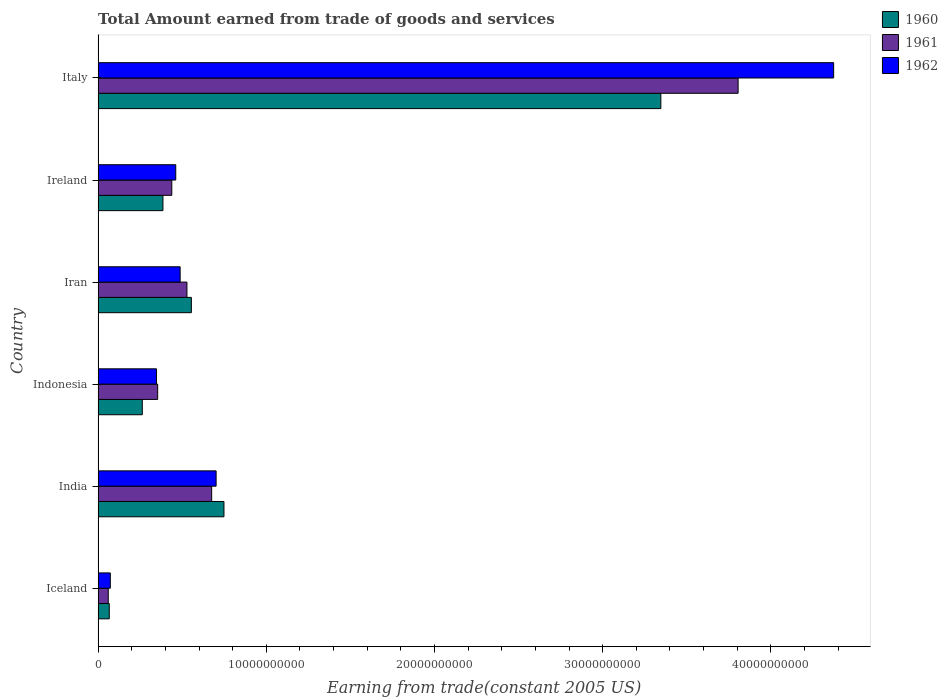How many different coloured bars are there?
Offer a very short reply. 3. How many groups of bars are there?
Your answer should be very brief. 6. How many bars are there on the 3rd tick from the top?
Provide a short and direct response. 3. In how many cases, is the number of bars for a given country not equal to the number of legend labels?
Your answer should be very brief. 0. What is the total amount earned by trading goods and services in 1962 in Ireland?
Your response must be concise. 4.62e+09. Across all countries, what is the maximum total amount earned by trading goods and services in 1961?
Your response must be concise. 3.81e+1. Across all countries, what is the minimum total amount earned by trading goods and services in 1961?
Your answer should be very brief. 6.03e+08. What is the total total amount earned by trading goods and services in 1962 in the graph?
Make the answer very short. 6.44e+1. What is the difference between the total amount earned by trading goods and services in 1960 in Indonesia and that in Italy?
Offer a very short reply. -3.08e+1. What is the difference between the total amount earned by trading goods and services in 1962 in Iceland and the total amount earned by trading goods and services in 1960 in Indonesia?
Your response must be concise. -1.90e+09. What is the average total amount earned by trading goods and services in 1961 per country?
Your answer should be very brief. 9.77e+09. What is the difference between the total amount earned by trading goods and services in 1961 and total amount earned by trading goods and services in 1962 in Iceland?
Provide a succinct answer. -1.22e+08. What is the ratio of the total amount earned by trading goods and services in 1962 in Iceland to that in Iran?
Offer a very short reply. 0.15. Is the total amount earned by trading goods and services in 1962 in India less than that in Iran?
Your response must be concise. No. What is the difference between the highest and the second highest total amount earned by trading goods and services in 1961?
Ensure brevity in your answer.  3.13e+1. What is the difference between the highest and the lowest total amount earned by trading goods and services in 1961?
Your answer should be compact. 3.74e+1. Is the sum of the total amount earned by trading goods and services in 1961 in Iran and Ireland greater than the maximum total amount earned by trading goods and services in 1960 across all countries?
Your answer should be compact. No. What does the 3rd bar from the top in Italy represents?
Your answer should be very brief. 1960. What does the 1st bar from the bottom in Ireland represents?
Make the answer very short. 1960. Is it the case that in every country, the sum of the total amount earned by trading goods and services in 1961 and total amount earned by trading goods and services in 1960 is greater than the total amount earned by trading goods and services in 1962?
Your answer should be very brief. Yes. How many bars are there?
Offer a very short reply. 18. How many countries are there in the graph?
Offer a very short reply. 6. Are the values on the major ticks of X-axis written in scientific E-notation?
Your answer should be very brief. No. Where does the legend appear in the graph?
Offer a terse response. Top right. How many legend labels are there?
Provide a succinct answer. 3. What is the title of the graph?
Offer a very short reply. Total Amount earned from trade of goods and services. What is the label or title of the X-axis?
Provide a succinct answer. Earning from trade(constant 2005 US). What is the Earning from trade(constant 2005 US) in 1960 in Iceland?
Provide a succinct answer. 6.63e+08. What is the Earning from trade(constant 2005 US) in 1961 in Iceland?
Your answer should be very brief. 6.03e+08. What is the Earning from trade(constant 2005 US) in 1962 in Iceland?
Offer a terse response. 7.25e+08. What is the Earning from trade(constant 2005 US) of 1960 in India?
Provide a succinct answer. 7.48e+09. What is the Earning from trade(constant 2005 US) in 1961 in India?
Make the answer very short. 6.75e+09. What is the Earning from trade(constant 2005 US) of 1962 in India?
Offer a very short reply. 7.02e+09. What is the Earning from trade(constant 2005 US) of 1960 in Indonesia?
Your response must be concise. 2.63e+09. What is the Earning from trade(constant 2005 US) of 1961 in Indonesia?
Provide a succinct answer. 3.54e+09. What is the Earning from trade(constant 2005 US) in 1962 in Indonesia?
Provide a succinct answer. 3.47e+09. What is the Earning from trade(constant 2005 US) in 1960 in Iran?
Ensure brevity in your answer.  5.54e+09. What is the Earning from trade(constant 2005 US) of 1961 in Iran?
Your answer should be compact. 5.28e+09. What is the Earning from trade(constant 2005 US) in 1962 in Iran?
Offer a very short reply. 4.88e+09. What is the Earning from trade(constant 2005 US) in 1960 in Ireland?
Your response must be concise. 3.85e+09. What is the Earning from trade(constant 2005 US) in 1961 in Ireland?
Your response must be concise. 4.38e+09. What is the Earning from trade(constant 2005 US) of 1962 in Ireland?
Your answer should be compact. 4.62e+09. What is the Earning from trade(constant 2005 US) of 1960 in Italy?
Keep it short and to the point. 3.35e+1. What is the Earning from trade(constant 2005 US) in 1961 in Italy?
Your answer should be very brief. 3.81e+1. What is the Earning from trade(constant 2005 US) of 1962 in Italy?
Provide a succinct answer. 4.37e+1. Across all countries, what is the maximum Earning from trade(constant 2005 US) in 1960?
Your answer should be very brief. 3.35e+1. Across all countries, what is the maximum Earning from trade(constant 2005 US) of 1961?
Offer a terse response. 3.81e+1. Across all countries, what is the maximum Earning from trade(constant 2005 US) in 1962?
Your answer should be compact. 4.37e+1. Across all countries, what is the minimum Earning from trade(constant 2005 US) in 1960?
Make the answer very short. 6.63e+08. Across all countries, what is the minimum Earning from trade(constant 2005 US) in 1961?
Provide a succinct answer. 6.03e+08. Across all countries, what is the minimum Earning from trade(constant 2005 US) in 1962?
Keep it short and to the point. 7.25e+08. What is the total Earning from trade(constant 2005 US) in 1960 in the graph?
Keep it short and to the point. 5.36e+1. What is the total Earning from trade(constant 2005 US) in 1961 in the graph?
Your answer should be very brief. 5.86e+1. What is the total Earning from trade(constant 2005 US) in 1962 in the graph?
Your answer should be very brief. 6.44e+1. What is the difference between the Earning from trade(constant 2005 US) in 1960 in Iceland and that in India?
Ensure brevity in your answer.  -6.82e+09. What is the difference between the Earning from trade(constant 2005 US) of 1961 in Iceland and that in India?
Your answer should be very brief. -6.15e+09. What is the difference between the Earning from trade(constant 2005 US) in 1962 in Iceland and that in India?
Keep it short and to the point. -6.29e+09. What is the difference between the Earning from trade(constant 2005 US) of 1960 in Iceland and that in Indonesia?
Provide a succinct answer. -1.96e+09. What is the difference between the Earning from trade(constant 2005 US) of 1961 in Iceland and that in Indonesia?
Offer a terse response. -2.94e+09. What is the difference between the Earning from trade(constant 2005 US) of 1962 in Iceland and that in Indonesia?
Ensure brevity in your answer.  -2.75e+09. What is the difference between the Earning from trade(constant 2005 US) in 1960 in Iceland and that in Iran?
Give a very brief answer. -4.88e+09. What is the difference between the Earning from trade(constant 2005 US) of 1961 in Iceland and that in Iran?
Your response must be concise. -4.68e+09. What is the difference between the Earning from trade(constant 2005 US) of 1962 in Iceland and that in Iran?
Offer a very short reply. -4.15e+09. What is the difference between the Earning from trade(constant 2005 US) of 1960 in Iceland and that in Ireland?
Provide a short and direct response. -3.19e+09. What is the difference between the Earning from trade(constant 2005 US) of 1961 in Iceland and that in Ireland?
Provide a short and direct response. -3.78e+09. What is the difference between the Earning from trade(constant 2005 US) of 1962 in Iceland and that in Ireland?
Give a very brief answer. -3.89e+09. What is the difference between the Earning from trade(constant 2005 US) of 1960 in Iceland and that in Italy?
Make the answer very short. -3.28e+1. What is the difference between the Earning from trade(constant 2005 US) of 1961 in Iceland and that in Italy?
Ensure brevity in your answer.  -3.74e+1. What is the difference between the Earning from trade(constant 2005 US) in 1962 in Iceland and that in Italy?
Your answer should be very brief. -4.30e+1. What is the difference between the Earning from trade(constant 2005 US) of 1960 in India and that in Indonesia?
Your answer should be compact. 4.85e+09. What is the difference between the Earning from trade(constant 2005 US) of 1961 in India and that in Indonesia?
Make the answer very short. 3.21e+09. What is the difference between the Earning from trade(constant 2005 US) in 1962 in India and that in Indonesia?
Your answer should be compact. 3.54e+09. What is the difference between the Earning from trade(constant 2005 US) in 1960 in India and that in Iran?
Your answer should be very brief. 1.94e+09. What is the difference between the Earning from trade(constant 2005 US) of 1961 in India and that in Iran?
Ensure brevity in your answer.  1.47e+09. What is the difference between the Earning from trade(constant 2005 US) of 1962 in India and that in Iran?
Your response must be concise. 2.14e+09. What is the difference between the Earning from trade(constant 2005 US) of 1960 in India and that in Ireland?
Make the answer very short. 3.63e+09. What is the difference between the Earning from trade(constant 2005 US) of 1961 in India and that in Ireland?
Your answer should be compact. 2.37e+09. What is the difference between the Earning from trade(constant 2005 US) of 1962 in India and that in Ireland?
Ensure brevity in your answer.  2.40e+09. What is the difference between the Earning from trade(constant 2005 US) in 1960 in India and that in Italy?
Your response must be concise. -2.60e+1. What is the difference between the Earning from trade(constant 2005 US) of 1961 in India and that in Italy?
Your response must be concise. -3.13e+1. What is the difference between the Earning from trade(constant 2005 US) of 1962 in India and that in Italy?
Give a very brief answer. -3.67e+1. What is the difference between the Earning from trade(constant 2005 US) of 1960 in Indonesia and that in Iran?
Offer a very short reply. -2.92e+09. What is the difference between the Earning from trade(constant 2005 US) of 1961 in Indonesia and that in Iran?
Ensure brevity in your answer.  -1.74e+09. What is the difference between the Earning from trade(constant 2005 US) of 1962 in Indonesia and that in Iran?
Offer a very short reply. -1.40e+09. What is the difference between the Earning from trade(constant 2005 US) in 1960 in Indonesia and that in Ireland?
Your answer should be very brief. -1.23e+09. What is the difference between the Earning from trade(constant 2005 US) of 1961 in Indonesia and that in Ireland?
Your response must be concise. -8.41e+08. What is the difference between the Earning from trade(constant 2005 US) in 1962 in Indonesia and that in Ireland?
Your answer should be compact. -1.14e+09. What is the difference between the Earning from trade(constant 2005 US) of 1960 in Indonesia and that in Italy?
Your response must be concise. -3.08e+1. What is the difference between the Earning from trade(constant 2005 US) of 1961 in Indonesia and that in Italy?
Keep it short and to the point. -3.45e+1. What is the difference between the Earning from trade(constant 2005 US) in 1962 in Indonesia and that in Italy?
Ensure brevity in your answer.  -4.03e+1. What is the difference between the Earning from trade(constant 2005 US) of 1960 in Iran and that in Ireland?
Give a very brief answer. 1.69e+09. What is the difference between the Earning from trade(constant 2005 US) in 1961 in Iran and that in Ireland?
Provide a short and direct response. 9.00e+08. What is the difference between the Earning from trade(constant 2005 US) in 1962 in Iran and that in Ireland?
Ensure brevity in your answer.  2.61e+08. What is the difference between the Earning from trade(constant 2005 US) in 1960 in Iran and that in Italy?
Keep it short and to the point. -2.79e+1. What is the difference between the Earning from trade(constant 2005 US) of 1961 in Iran and that in Italy?
Make the answer very short. -3.28e+1. What is the difference between the Earning from trade(constant 2005 US) of 1962 in Iran and that in Italy?
Offer a terse response. -3.89e+1. What is the difference between the Earning from trade(constant 2005 US) of 1960 in Ireland and that in Italy?
Give a very brief answer. -2.96e+1. What is the difference between the Earning from trade(constant 2005 US) of 1961 in Ireland and that in Italy?
Your response must be concise. -3.37e+1. What is the difference between the Earning from trade(constant 2005 US) in 1962 in Ireland and that in Italy?
Make the answer very short. -3.91e+1. What is the difference between the Earning from trade(constant 2005 US) of 1960 in Iceland and the Earning from trade(constant 2005 US) of 1961 in India?
Provide a short and direct response. -6.09e+09. What is the difference between the Earning from trade(constant 2005 US) of 1960 in Iceland and the Earning from trade(constant 2005 US) of 1962 in India?
Give a very brief answer. -6.35e+09. What is the difference between the Earning from trade(constant 2005 US) in 1961 in Iceland and the Earning from trade(constant 2005 US) in 1962 in India?
Ensure brevity in your answer.  -6.41e+09. What is the difference between the Earning from trade(constant 2005 US) of 1960 in Iceland and the Earning from trade(constant 2005 US) of 1961 in Indonesia?
Keep it short and to the point. -2.88e+09. What is the difference between the Earning from trade(constant 2005 US) of 1960 in Iceland and the Earning from trade(constant 2005 US) of 1962 in Indonesia?
Your answer should be very brief. -2.81e+09. What is the difference between the Earning from trade(constant 2005 US) in 1961 in Iceland and the Earning from trade(constant 2005 US) in 1962 in Indonesia?
Offer a terse response. -2.87e+09. What is the difference between the Earning from trade(constant 2005 US) of 1960 in Iceland and the Earning from trade(constant 2005 US) of 1961 in Iran?
Your response must be concise. -4.62e+09. What is the difference between the Earning from trade(constant 2005 US) of 1960 in Iceland and the Earning from trade(constant 2005 US) of 1962 in Iran?
Make the answer very short. -4.21e+09. What is the difference between the Earning from trade(constant 2005 US) in 1961 in Iceland and the Earning from trade(constant 2005 US) in 1962 in Iran?
Offer a terse response. -4.27e+09. What is the difference between the Earning from trade(constant 2005 US) in 1960 in Iceland and the Earning from trade(constant 2005 US) in 1961 in Ireland?
Offer a very short reply. -3.72e+09. What is the difference between the Earning from trade(constant 2005 US) of 1960 in Iceland and the Earning from trade(constant 2005 US) of 1962 in Ireland?
Ensure brevity in your answer.  -3.95e+09. What is the difference between the Earning from trade(constant 2005 US) of 1961 in Iceland and the Earning from trade(constant 2005 US) of 1962 in Ireland?
Give a very brief answer. -4.01e+09. What is the difference between the Earning from trade(constant 2005 US) of 1960 in Iceland and the Earning from trade(constant 2005 US) of 1961 in Italy?
Offer a terse response. -3.74e+1. What is the difference between the Earning from trade(constant 2005 US) in 1960 in Iceland and the Earning from trade(constant 2005 US) in 1962 in Italy?
Give a very brief answer. -4.31e+1. What is the difference between the Earning from trade(constant 2005 US) in 1961 in Iceland and the Earning from trade(constant 2005 US) in 1962 in Italy?
Your response must be concise. -4.31e+1. What is the difference between the Earning from trade(constant 2005 US) in 1960 in India and the Earning from trade(constant 2005 US) in 1961 in Indonesia?
Provide a succinct answer. 3.94e+09. What is the difference between the Earning from trade(constant 2005 US) of 1960 in India and the Earning from trade(constant 2005 US) of 1962 in Indonesia?
Your answer should be compact. 4.01e+09. What is the difference between the Earning from trade(constant 2005 US) of 1961 in India and the Earning from trade(constant 2005 US) of 1962 in Indonesia?
Give a very brief answer. 3.28e+09. What is the difference between the Earning from trade(constant 2005 US) in 1960 in India and the Earning from trade(constant 2005 US) in 1961 in Iran?
Your response must be concise. 2.20e+09. What is the difference between the Earning from trade(constant 2005 US) in 1960 in India and the Earning from trade(constant 2005 US) in 1962 in Iran?
Make the answer very short. 2.60e+09. What is the difference between the Earning from trade(constant 2005 US) of 1961 in India and the Earning from trade(constant 2005 US) of 1962 in Iran?
Provide a succinct answer. 1.87e+09. What is the difference between the Earning from trade(constant 2005 US) of 1960 in India and the Earning from trade(constant 2005 US) of 1961 in Ireland?
Keep it short and to the point. 3.10e+09. What is the difference between the Earning from trade(constant 2005 US) of 1960 in India and the Earning from trade(constant 2005 US) of 1962 in Ireland?
Provide a succinct answer. 2.87e+09. What is the difference between the Earning from trade(constant 2005 US) in 1961 in India and the Earning from trade(constant 2005 US) in 1962 in Ireland?
Offer a terse response. 2.14e+09. What is the difference between the Earning from trade(constant 2005 US) in 1960 in India and the Earning from trade(constant 2005 US) in 1961 in Italy?
Your answer should be very brief. -3.06e+1. What is the difference between the Earning from trade(constant 2005 US) in 1960 in India and the Earning from trade(constant 2005 US) in 1962 in Italy?
Offer a terse response. -3.62e+1. What is the difference between the Earning from trade(constant 2005 US) in 1961 in India and the Earning from trade(constant 2005 US) in 1962 in Italy?
Keep it short and to the point. -3.70e+1. What is the difference between the Earning from trade(constant 2005 US) in 1960 in Indonesia and the Earning from trade(constant 2005 US) in 1961 in Iran?
Offer a terse response. -2.65e+09. What is the difference between the Earning from trade(constant 2005 US) in 1960 in Indonesia and the Earning from trade(constant 2005 US) in 1962 in Iran?
Ensure brevity in your answer.  -2.25e+09. What is the difference between the Earning from trade(constant 2005 US) of 1961 in Indonesia and the Earning from trade(constant 2005 US) of 1962 in Iran?
Provide a short and direct response. -1.34e+09. What is the difference between the Earning from trade(constant 2005 US) of 1960 in Indonesia and the Earning from trade(constant 2005 US) of 1961 in Ireland?
Offer a terse response. -1.75e+09. What is the difference between the Earning from trade(constant 2005 US) of 1960 in Indonesia and the Earning from trade(constant 2005 US) of 1962 in Ireland?
Your answer should be very brief. -1.99e+09. What is the difference between the Earning from trade(constant 2005 US) of 1961 in Indonesia and the Earning from trade(constant 2005 US) of 1962 in Ireland?
Your response must be concise. -1.08e+09. What is the difference between the Earning from trade(constant 2005 US) of 1960 in Indonesia and the Earning from trade(constant 2005 US) of 1961 in Italy?
Offer a terse response. -3.54e+1. What is the difference between the Earning from trade(constant 2005 US) of 1960 in Indonesia and the Earning from trade(constant 2005 US) of 1962 in Italy?
Provide a succinct answer. -4.11e+1. What is the difference between the Earning from trade(constant 2005 US) in 1961 in Indonesia and the Earning from trade(constant 2005 US) in 1962 in Italy?
Provide a short and direct response. -4.02e+1. What is the difference between the Earning from trade(constant 2005 US) of 1960 in Iran and the Earning from trade(constant 2005 US) of 1961 in Ireland?
Make the answer very short. 1.16e+09. What is the difference between the Earning from trade(constant 2005 US) of 1960 in Iran and the Earning from trade(constant 2005 US) of 1962 in Ireland?
Offer a terse response. 9.28e+08. What is the difference between the Earning from trade(constant 2005 US) in 1961 in Iran and the Earning from trade(constant 2005 US) in 1962 in Ireland?
Offer a very short reply. 6.65e+08. What is the difference between the Earning from trade(constant 2005 US) in 1960 in Iran and the Earning from trade(constant 2005 US) in 1961 in Italy?
Provide a short and direct response. -3.25e+1. What is the difference between the Earning from trade(constant 2005 US) of 1960 in Iran and the Earning from trade(constant 2005 US) of 1962 in Italy?
Your response must be concise. -3.82e+1. What is the difference between the Earning from trade(constant 2005 US) of 1961 in Iran and the Earning from trade(constant 2005 US) of 1962 in Italy?
Make the answer very short. -3.85e+1. What is the difference between the Earning from trade(constant 2005 US) in 1960 in Ireland and the Earning from trade(constant 2005 US) in 1961 in Italy?
Ensure brevity in your answer.  -3.42e+1. What is the difference between the Earning from trade(constant 2005 US) of 1960 in Ireland and the Earning from trade(constant 2005 US) of 1962 in Italy?
Offer a terse response. -3.99e+1. What is the difference between the Earning from trade(constant 2005 US) of 1961 in Ireland and the Earning from trade(constant 2005 US) of 1962 in Italy?
Provide a succinct answer. -3.93e+1. What is the average Earning from trade(constant 2005 US) of 1960 per country?
Give a very brief answer. 8.94e+09. What is the average Earning from trade(constant 2005 US) in 1961 per country?
Provide a succinct answer. 9.77e+09. What is the average Earning from trade(constant 2005 US) of 1962 per country?
Your response must be concise. 1.07e+1. What is the difference between the Earning from trade(constant 2005 US) of 1960 and Earning from trade(constant 2005 US) of 1961 in Iceland?
Keep it short and to the point. 6.00e+07. What is the difference between the Earning from trade(constant 2005 US) in 1960 and Earning from trade(constant 2005 US) in 1962 in Iceland?
Offer a very short reply. -6.22e+07. What is the difference between the Earning from trade(constant 2005 US) of 1961 and Earning from trade(constant 2005 US) of 1962 in Iceland?
Give a very brief answer. -1.22e+08. What is the difference between the Earning from trade(constant 2005 US) in 1960 and Earning from trade(constant 2005 US) in 1961 in India?
Give a very brief answer. 7.30e+08. What is the difference between the Earning from trade(constant 2005 US) of 1960 and Earning from trade(constant 2005 US) of 1962 in India?
Provide a short and direct response. 4.66e+08. What is the difference between the Earning from trade(constant 2005 US) of 1961 and Earning from trade(constant 2005 US) of 1962 in India?
Offer a very short reply. -2.64e+08. What is the difference between the Earning from trade(constant 2005 US) of 1960 and Earning from trade(constant 2005 US) of 1961 in Indonesia?
Ensure brevity in your answer.  -9.14e+08. What is the difference between the Earning from trade(constant 2005 US) of 1960 and Earning from trade(constant 2005 US) of 1962 in Indonesia?
Provide a succinct answer. -8.46e+08. What is the difference between the Earning from trade(constant 2005 US) of 1961 and Earning from trade(constant 2005 US) of 1962 in Indonesia?
Your answer should be very brief. 6.82e+07. What is the difference between the Earning from trade(constant 2005 US) of 1960 and Earning from trade(constant 2005 US) of 1961 in Iran?
Your answer should be compact. 2.63e+08. What is the difference between the Earning from trade(constant 2005 US) of 1960 and Earning from trade(constant 2005 US) of 1962 in Iran?
Your answer should be compact. 6.67e+08. What is the difference between the Earning from trade(constant 2005 US) of 1961 and Earning from trade(constant 2005 US) of 1962 in Iran?
Keep it short and to the point. 4.04e+08. What is the difference between the Earning from trade(constant 2005 US) in 1960 and Earning from trade(constant 2005 US) in 1961 in Ireland?
Give a very brief answer. -5.28e+08. What is the difference between the Earning from trade(constant 2005 US) of 1960 and Earning from trade(constant 2005 US) of 1962 in Ireland?
Your answer should be very brief. -7.62e+08. What is the difference between the Earning from trade(constant 2005 US) of 1961 and Earning from trade(constant 2005 US) of 1962 in Ireland?
Ensure brevity in your answer.  -2.34e+08. What is the difference between the Earning from trade(constant 2005 US) of 1960 and Earning from trade(constant 2005 US) of 1961 in Italy?
Provide a succinct answer. -4.59e+09. What is the difference between the Earning from trade(constant 2005 US) of 1960 and Earning from trade(constant 2005 US) of 1962 in Italy?
Your response must be concise. -1.03e+1. What is the difference between the Earning from trade(constant 2005 US) in 1961 and Earning from trade(constant 2005 US) in 1962 in Italy?
Your answer should be compact. -5.68e+09. What is the ratio of the Earning from trade(constant 2005 US) of 1960 in Iceland to that in India?
Provide a succinct answer. 0.09. What is the ratio of the Earning from trade(constant 2005 US) in 1961 in Iceland to that in India?
Offer a very short reply. 0.09. What is the ratio of the Earning from trade(constant 2005 US) of 1962 in Iceland to that in India?
Ensure brevity in your answer.  0.1. What is the ratio of the Earning from trade(constant 2005 US) of 1960 in Iceland to that in Indonesia?
Give a very brief answer. 0.25. What is the ratio of the Earning from trade(constant 2005 US) of 1961 in Iceland to that in Indonesia?
Keep it short and to the point. 0.17. What is the ratio of the Earning from trade(constant 2005 US) of 1962 in Iceland to that in Indonesia?
Keep it short and to the point. 0.21. What is the ratio of the Earning from trade(constant 2005 US) of 1960 in Iceland to that in Iran?
Offer a terse response. 0.12. What is the ratio of the Earning from trade(constant 2005 US) in 1961 in Iceland to that in Iran?
Provide a short and direct response. 0.11. What is the ratio of the Earning from trade(constant 2005 US) of 1962 in Iceland to that in Iran?
Your answer should be compact. 0.15. What is the ratio of the Earning from trade(constant 2005 US) in 1960 in Iceland to that in Ireland?
Provide a succinct answer. 0.17. What is the ratio of the Earning from trade(constant 2005 US) in 1961 in Iceland to that in Ireland?
Ensure brevity in your answer.  0.14. What is the ratio of the Earning from trade(constant 2005 US) of 1962 in Iceland to that in Ireland?
Your answer should be very brief. 0.16. What is the ratio of the Earning from trade(constant 2005 US) in 1960 in Iceland to that in Italy?
Provide a short and direct response. 0.02. What is the ratio of the Earning from trade(constant 2005 US) in 1961 in Iceland to that in Italy?
Make the answer very short. 0.02. What is the ratio of the Earning from trade(constant 2005 US) of 1962 in Iceland to that in Italy?
Offer a very short reply. 0.02. What is the ratio of the Earning from trade(constant 2005 US) in 1960 in India to that in Indonesia?
Give a very brief answer. 2.85. What is the ratio of the Earning from trade(constant 2005 US) of 1961 in India to that in Indonesia?
Give a very brief answer. 1.91. What is the ratio of the Earning from trade(constant 2005 US) in 1962 in India to that in Indonesia?
Your answer should be very brief. 2.02. What is the ratio of the Earning from trade(constant 2005 US) in 1960 in India to that in Iran?
Offer a terse response. 1.35. What is the ratio of the Earning from trade(constant 2005 US) of 1961 in India to that in Iran?
Your response must be concise. 1.28. What is the ratio of the Earning from trade(constant 2005 US) in 1962 in India to that in Iran?
Provide a succinct answer. 1.44. What is the ratio of the Earning from trade(constant 2005 US) in 1960 in India to that in Ireland?
Offer a terse response. 1.94. What is the ratio of the Earning from trade(constant 2005 US) of 1961 in India to that in Ireland?
Offer a very short reply. 1.54. What is the ratio of the Earning from trade(constant 2005 US) of 1962 in India to that in Ireland?
Give a very brief answer. 1.52. What is the ratio of the Earning from trade(constant 2005 US) in 1960 in India to that in Italy?
Provide a succinct answer. 0.22. What is the ratio of the Earning from trade(constant 2005 US) of 1961 in India to that in Italy?
Keep it short and to the point. 0.18. What is the ratio of the Earning from trade(constant 2005 US) of 1962 in India to that in Italy?
Your answer should be very brief. 0.16. What is the ratio of the Earning from trade(constant 2005 US) in 1960 in Indonesia to that in Iran?
Keep it short and to the point. 0.47. What is the ratio of the Earning from trade(constant 2005 US) in 1961 in Indonesia to that in Iran?
Your answer should be very brief. 0.67. What is the ratio of the Earning from trade(constant 2005 US) in 1962 in Indonesia to that in Iran?
Ensure brevity in your answer.  0.71. What is the ratio of the Earning from trade(constant 2005 US) in 1960 in Indonesia to that in Ireland?
Provide a succinct answer. 0.68. What is the ratio of the Earning from trade(constant 2005 US) of 1961 in Indonesia to that in Ireland?
Your answer should be very brief. 0.81. What is the ratio of the Earning from trade(constant 2005 US) in 1962 in Indonesia to that in Ireland?
Your response must be concise. 0.75. What is the ratio of the Earning from trade(constant 2005 US) of 1960 in Indonesia to that in Italy?
Provide a short and direct response. 0.08. What is the ratio of the Earning from trade(constant 2005 US) in 1961 in Indonesia to that in Italy?
Give a very brief answer. 0.09. What is the ratio of the Earning from trade(constant 2005 US) of 1962 in Indonesia to that in Italy?
Offer a terse response. 0.08. What is the ratio of the Earning from trade(constant 2005 US) of 1960 in Iran to that in Ireland?
Provide a short and direct response. 1.44. What is the ratio of the Earning from trade(constant 2005 US) of 1961 in Iran to that in Ireland?
Your response must be concise. 1.21. What is the ratio of the Earning from trade(constant 2005 US) in 1962 in Iran to that in Ireland?
Offer a terse response. 1.06. What is the ratio of the Earning from trade(constant 2005 US) in 1960 in Iran to that in Italy?
Offer a very short reply. 0.17. What is the ratio of the Earning from trade(constant 2005 US) of 1961 in Iran to that in Italy?
Your answer should be very brief. 0.14. What is the ratio of the Earning from trade(constant 2005 US) in 1962 in Iran to that in Italy?
Keep it short and to the point. 0.11. What is the ratio of the Earning from trade(constant 2005 US) of 1960 in Ireland to that in Italy?
Offer a very short reply. 0.12. What is the ratio of the Earning from trade(constant 2005 US) of 1961 in Ireland to that in Italy?
Keep it short and to the point. 0.12. What is the ratio of the Earning from trade(constant 2005 US) of 1962 in Ireland to that in Italy?
Keep it short and to the point. 0.11. What is the difference between the highest and the second highest Earning from trade(constant 2005 US) in 1960?
Provide a short and direct response. 2.60e+1. What is the difference between the highest and the second highest Earning from trade(constant 2005 US) in 1961?
Your response must be concise. 3.13e+1. What is the difference between the highest and the second highest Earning from trade(constant 2005 US) of 1962?
Offer a very short reply. 3.67e+1. What is the difference between the highest and the lowest Earning from trade(constant 2005 US) in 1960?
Offer a terse response. 3.28e+1. What is the difference between the highest and the lowest Earning from trade(constant 2005 US) in 1961?
Offer a very short reply. 3.74e+1. What is the difference between the highest and the lowest Earning from trade(constant 2005 US) in 1962?
Your answer should be compact. 4.30e+1. 